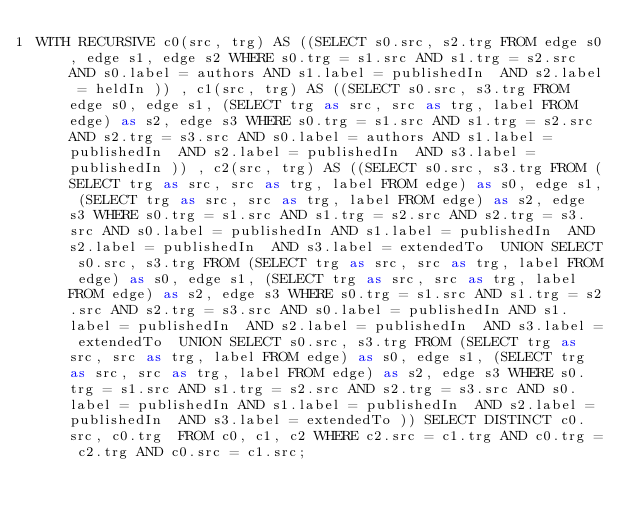<code> <loc_0><loc_0><loc_500><loc_500><_SQL_>WITH RECURSIVE c0(src, trg) AS ((SELECT s0.src, s2.trg FROM edge s0, edge s1, edge s2 WHERE s0.trg = s1.src AND s1.trg = s2.src AND s0.label = authors AND s1.label = publishedIn  AND s2.label = heldIn )) , c1(src, trg) AS ((SELECT s0.src, s3.trg FROM edge s0, edge s1, (SELECT trg as src, src as trg, label FROM edge) as s2, edge s3 WHERE s0.trg = s1.src AND s1.trg = s2.src AND s2.trg = s3.src AND s0.label = authors AND s1.label = publishedIn  AND s2.label = publishedIn  AND s3.label = publishedIn )) , c2(src, trg) AS ((SELECT s0.src, s3.trg FROM (SELECT trg as src, src as trg, label FROM edge) as s0, edge s1, (SELECT trg as src, src as trg, label FROM edge) as s2, edge s3 WHERE s0.trg = s1.src AND s1.trg = s2.src AND s2.trg = s3.src AND s0.label = publishedIn AND s1.label = publishedIn  AND s2.label = publishedIn  AND s3.label = extendedTo  UNION SELECT s0.src, s3.trg FROM (SELECT trg as src, src as trg, label FROM edge) as s0, edge s1, (SELECT trg as src, src as trg, label FROM edge) as s2, edge s3 WHERE s0.trg = s1.src AND s1.trg = s2.src AND s2.trg = s3.src AND s0.label = publishedIn AND s1.label = publishedIn  AND s2.label = publishedIn  AND s3.label = extendedTo  UNION SELECT s0.src, s3.trg FROM (SELECT trg as src, src as trg, label FROM edge) as s0, edge s1, (SELECT trg as src, src as trg, label FROM edge) as s2, edge s3 WHERE s0.trg = s1.src AND s1.trg = s2.src AND s2.trg = s3.src AND s0.label = publishedIn AND s1.label = publishedIn  AND s2.label = publishedIn  AND s3.label = extendedTo )) SELECT DISTINCT c0.src, c0.trg  FROM c0, c1, c2 WHERE c2.src = c1.trg AND c0.trg = c2.trg AND c0.src = c1.src;
</code> 